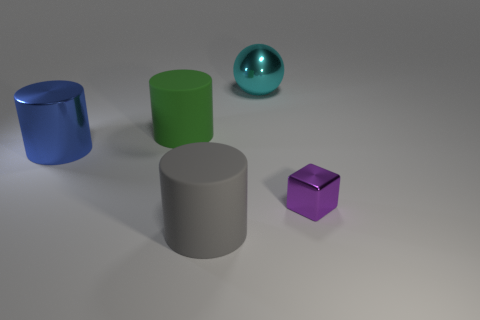Are there any other things that have the same size as the purple shiny thing?
Give a very brief answer. No. Is there a large cylinder in front of the matte object that is behind the large matte thing that is in front of the small purple block?
Your answer should be compact. Yes. There is a rubber object that is in front of the blue cylinder; is it the same shape as the large matte thing that is on the left side of the gray thing?
Ensure brevity in your answer.  Yes. Is the number of large green things that are left of the metal block greater than the number of brown balls?
Offer a terse response. Yes. How many things are either tiny purple shiny cubes or cyan rubber things?
Give a very brief answer. 1. What color is the cube?
Provide a short and direct response. Purple. What number of other objects are the same color as the metallic ball?
Your response must be concise. 0. Are there any cylinders behind the green matte object?
Offer a terse response. No. The matte thing that is in front of the tiny thing that is behind the matte cylinder in front of the shiny cylinder is what color?
Provide a succinct answer. Gray. How many rubber things are both in front of the tiny purple metallic block and behind the small metal thing?
Your answer should be compact. 0. 